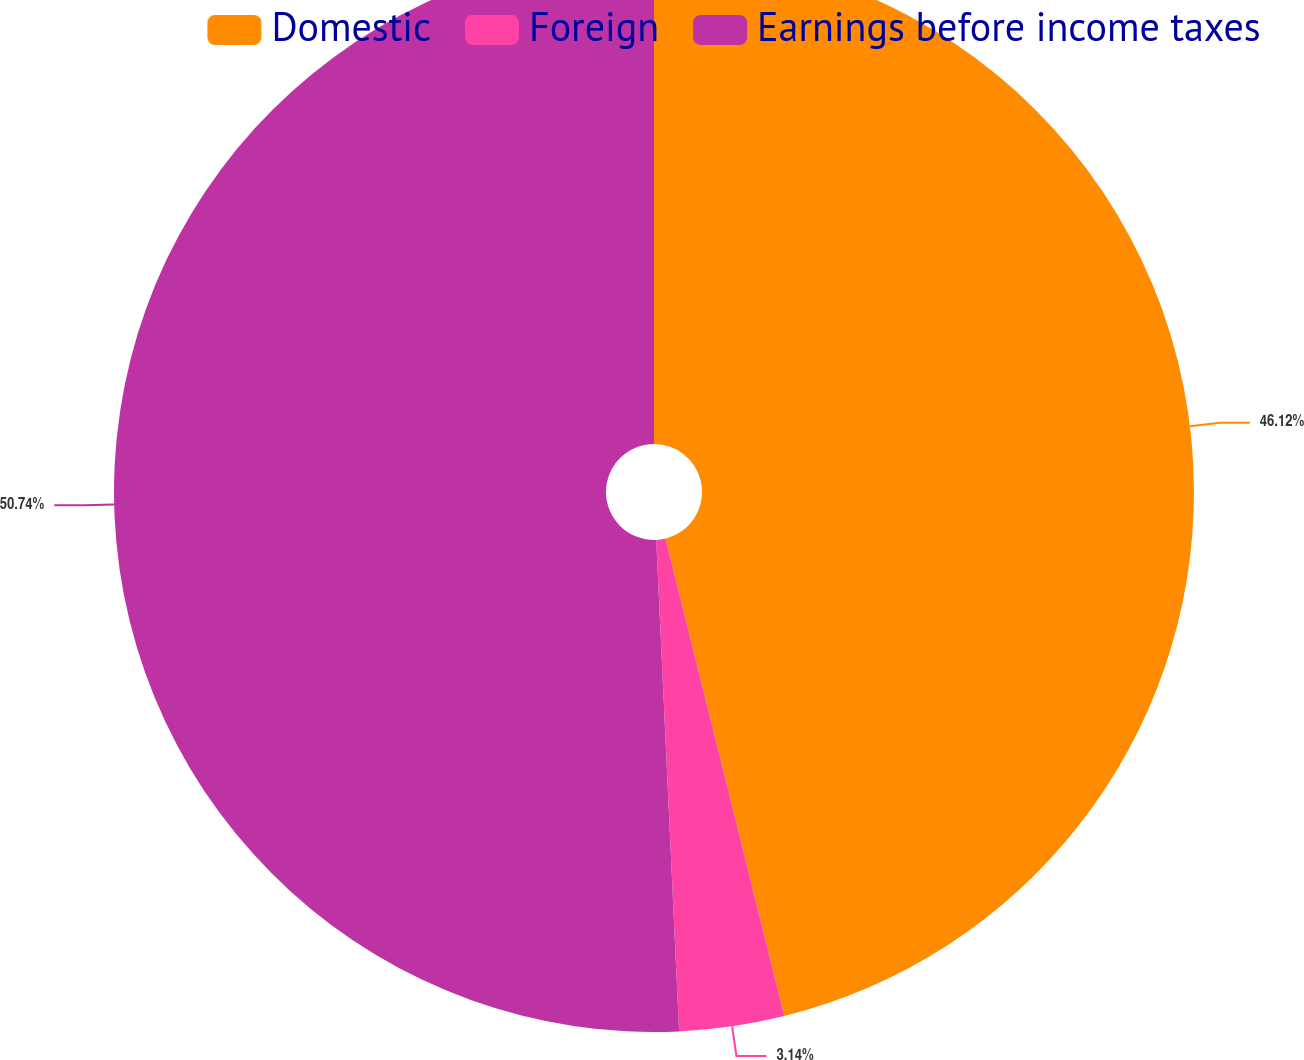Convert chart to OTSL. <chart><loc_0><loc_0><loc_500><loc_500><pie_chart><fcel>Domestic<fcel>Foreign<fcel>Earnings before income taxes<nl><fcel>46.12%<fcel>3.14%<fcel>50.74%<nl></chart> 